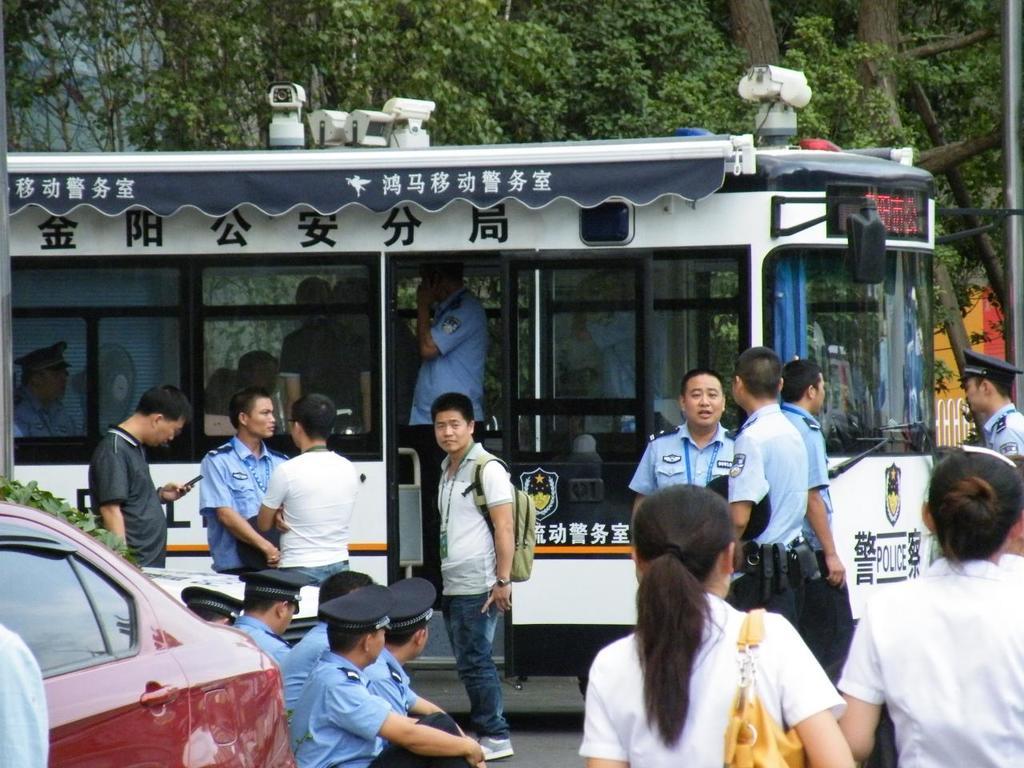What department is this vehicle for?
Your response must be concise. Police. What language has been used on the bus?
Your answer should be very brief. Unanswerable. 